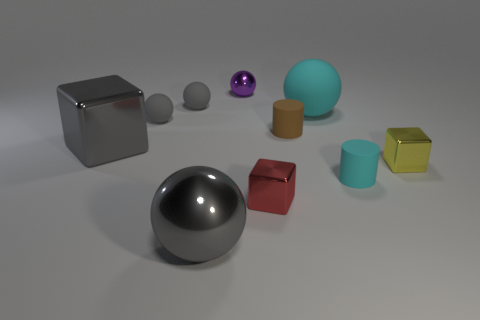Are there an equal number of tiny matte spheres right of the tiny cyan object and small gray things?
Offer a very short reply. No. How many other objects are there of the same material as the tiny cyan object?
Offer a very short reply. 4. There is a block that is on the left side of the small red block; is it the same size as the metal sphere on the right side of the gray metallic ball?
Provide a succinct answer. No. What number of objects are either things that are in front of the tiny red shiny cube or blocks behind the small red thing?
Ensure brevity in your answer.  3. Is there any other thing that has the same shape as the tiny brown matte thing?
Your answer should be very brief. Yes. Do the small block that is in front of the yellow metallic block and the metal thing on the right side of the small brown object have the same color?
Ensure brevity in your answer.  No. How many metallic objects are either tiny red cubes or big gray objects?
Make the answer very short. 3. Is there anything else that has the same size as the gray shiny block?
Your response must be concise. Yes. The big metal thing behind the block that is in front of the tiny cyan thing is what shape?
Offer a very short reply. Cube. Is the big ball that is in front of the big cyan sphere made of the same material as the tiny cylinder that is behind the yellow cube?
Give a very brief answer. No. 